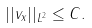<formula> <loc_0><loc_0><loc_500><loc_500>| | v _ { x } | | _ { L ^ { 2 } } \leq C .</formula> 